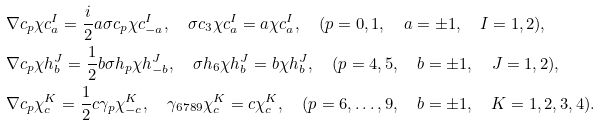<formula> <loc_0><loc_0><loc_500><loc_500>& \nabla c _ { p } \chi c ^ { I } _ { a } = \frac { i } { 2 } a \sigma c _ { p } \chi c ^ { I } _ { - a } , \quad \sigma c _ { 3 } \chi c ^ { I } _ { a } = a \chi c ^ { I } _ { a } , \quad ( p = 0 , 1 , \quad a = \pm 1 , \quad I = 1 , 2 ) , \\ & \nabla c _ { p } \chi h ^ { J } _ { b } = \frac { 1 } { 2 } b \sigma h _ { p } \chi h ^ { J } _ { - b } , \quad \sigma h _ { 6 } \chi h ^ { J } _ { b } = b \chi h ^ { J } _ { b } , \quad ( p = 4 , 5 , \quad b = \pm 1 , \quad J = 1 , 2 ) , \\ & \nabla c _ { p } \chi ^ { K } _ { c } = \frac { 1 } { 2 } c \gamma _ { p } \chi ^ { K } _ { - c } , \quad \gamma _ { 6 7 8 9 } \chi ^ { K } _ { c } = c \chi ^ { K } _ { c } , \quad ( p = 6 , \dots , 9 , \quad b = \pm 1 , \quad K = 1 , 2 , 3 , 4 ) .</formula> 